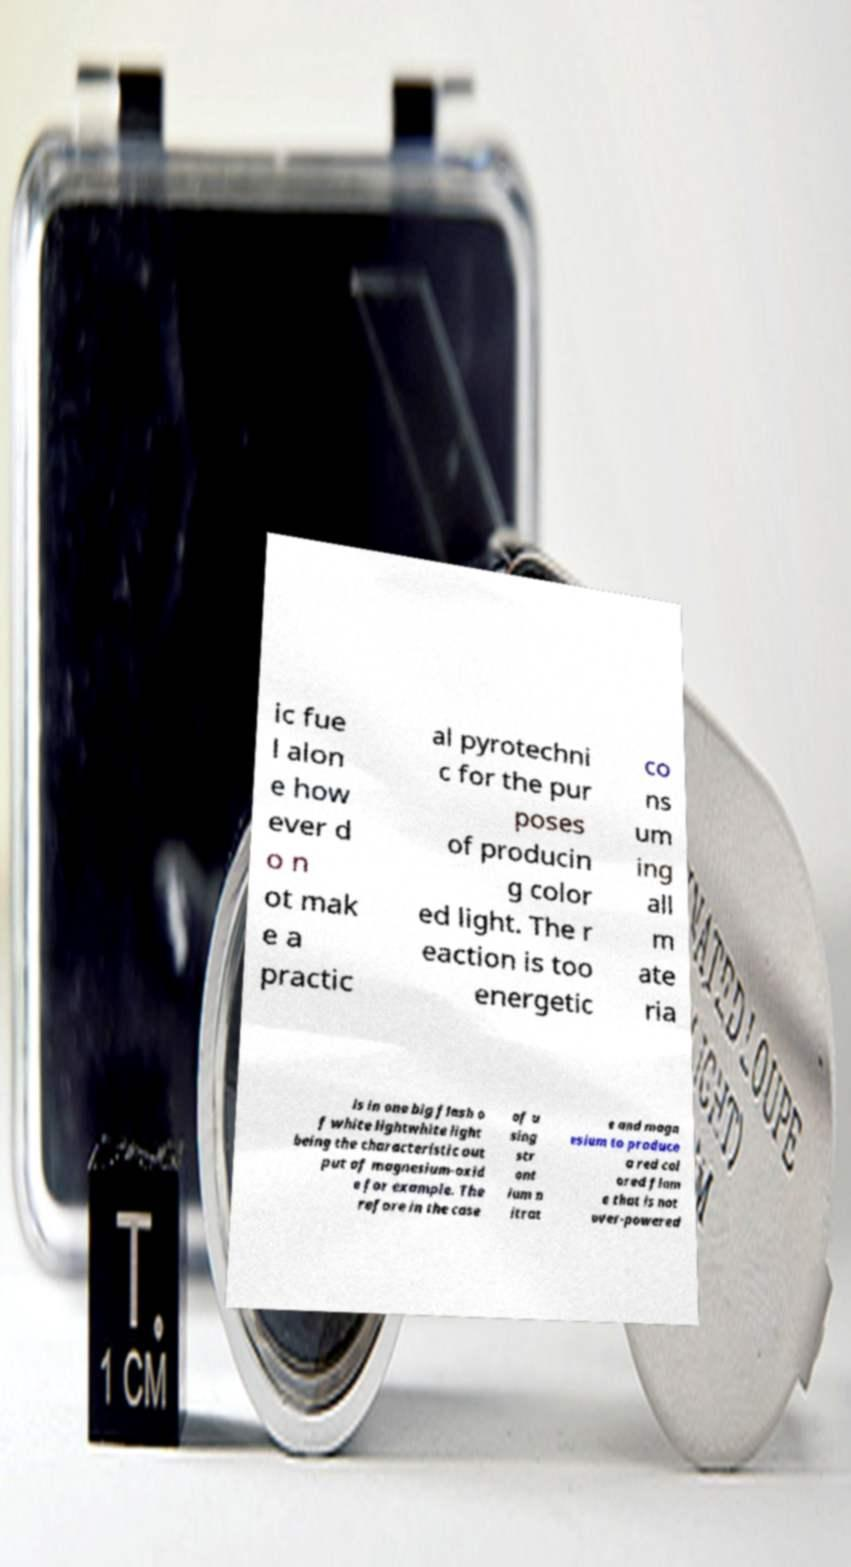There's text embedded in this image that I need extracted. Can you transcribe it verbatim? ic fue l alon e how ever d o n ot mak e a practic al pyrotechni c for the pur poses of producin g color ed light. The r eaction is too energetic co ns um ing all m ate ria ls in one big flash o f white lightwhite light being the characteristic out put of magnesium-oxid e for example. The refore in the case of u sing str ont ium n itrat e and magn esium to produce a red col ored flam e that is not over-powered 